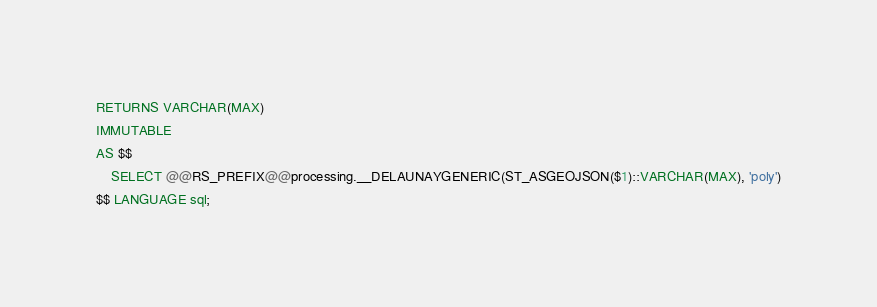Convert code to text. <code><loc_0><loc_0><loc_500><loc_500><_SQL_>RETURNS VARCHAR(MAX)
IMMUTABLE
AS $$
    SELECT @@RS_PREFIX@@processing.__DELAUNAYGENERIC(ST_ASGEOJSON($1)::VARCHAR(MAX), 'poly')
$$ LANGUAGE sql;</code> 